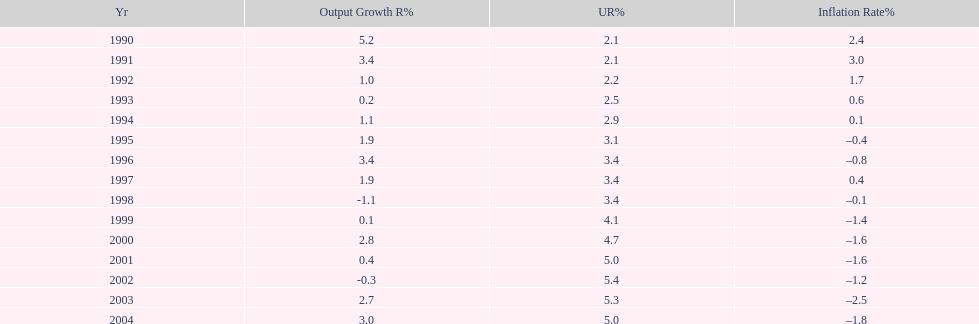What year had the highest unemployment rate? 2002. 